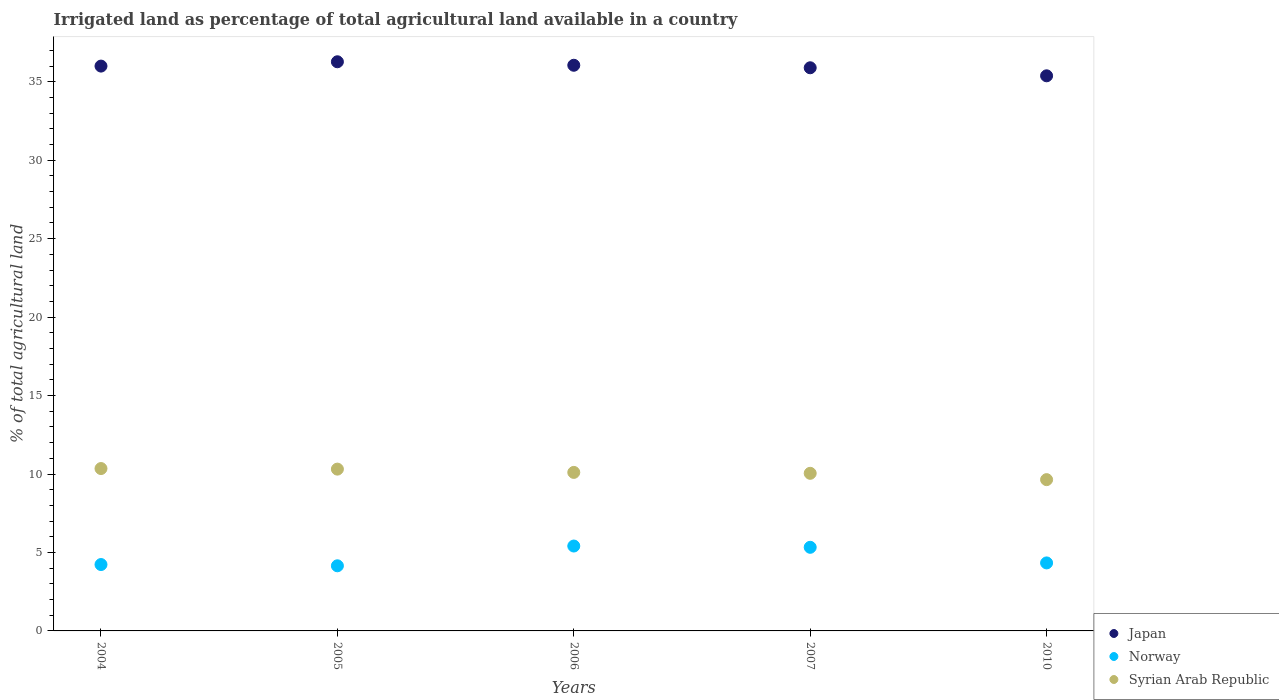What is the percentage of irrigated land in Syrian Arab Republic in 2006?
Give a very brief answer. 10.1. Across all years, what is the maximum percentage of irrigated land in Norway?
Offer a very short reply. 5.41. Across all years, what is the minimum percentage of irrigated land in Norway?
Make the answer very short. 4.15. In which year was the percentage of irrigated land in Syrian Arab Republic minimum?
Your answer should be compact. 2010. What is the total percentage of irrigated land in Japan in the graph?
Keep it short and to the point. 179.6. What is the difference between the percentage of irrigated land in Japan in 2005 and that in 2006?
Your response must be concise. 0.22. What is the difference between the percentage of irrigated land in Japan in 2006 and the percentage of irrigated land in Norway in 2007?
Provide a succinct answer. 30.72. What is the average percentage of irrigated land in Japan per year?
Ensure brevity in your answer.  35.92. In the year 2007, what is the difference between the percentage of irrigated land in Japan and percentage of irrigated land in Norway?
Offer a very short reply. 30.56. What is the ratio of the percentage of irrigated land in Norway in 2005 to that in 2007?
Provide a succinct answer. 0.78. Is the difference between the percentage of irrigated land in Japan in 2004 and 2006 greater than the difference between the percentage of irrigated land in Norway in 2004 and 2006?
Provide a succinct answer. Yes. What is the difference between the highest and the second highest percentage of irrigated land in Japan?
Provide a short and direct response. 0.22. What is the difference between the highest and the lowest percentage of irrigated land in Japan?
Ensure brevity in your answer.  0.89. Is it the case that in every year, the sum of the percentage of irrigated land in Norway and percentage of irrigated land in Syrian Arab Republic  is greater than the percentage of irrigated land in Japan?
Give a very brief answer. No. Is the percentage of irrigated land in Syrian Arab Republic strictly greater than the percentage of irrigated land in Norway over the years?
Make the answer very short. Yes. How many dotlines are there?
Give a very brief answer. 3. How many years are there in the graph?
Provide a short and direct response. 5. Are the values on the major ticks of Y-axis written in scientific E-notation?
Provide a short and direct response. No. Does the graph contain grids?
Give a very brief answer. No. How many legend labels are there?
Your answer should be very brief. 3. What is the title of the graph?
Your response must be concise. Irrigated land as percentage of total agricultural land available in a country. Does "High income: OECD" appear as one of the legend labels in the graph?
Offer a very short reply. No. What is the label or title of the Y-axis?
Your answer should be compact. % of total agricultural land. What is the % of total agricultural land in Japan in 2004?
Offer a terse response. 36. What is the % of total agricultural land of Norway in 2004?
Keep it short and to the point. 4.23. What is the % of total agricultural land in Syrian Arab Republic in 2004?
Provide a short and direct response. 10.35. What is the % of total agricultural land of Japan in 2005?
Provide a short and direct response. 36.27. What is the % of total agricultural land of Norway in 2005?
Keep it short and to the point. 4.15. What is the % of total agricultural land of Syrian Arab Republic in 2005?
Ensure brevity in your answer.  10.31. What is the % of total agricultural land in Japan in 2006?
Your answer should be compact. 36.05. What is the % of total agricultural land in Norway in 2006?
Your response must be concise. 5.41. What is the % of total agricultural land in Syrian Arab Republic in 2006?
Keep it short and to the point. 10.1. What is the % of total agricultural land in Japan in 2007?
Offer a very short reply. 35.89. What is the % of total agricultural land in Norway in 2007?
Your answer should be very brief. 5.33. What is the % of total agricultural land in Syrian Arab Republic in 2007?
Keep it short and to the point. 10.05. What is the % of total agricultural land of Japan in 2010?
Offer a very short reply. 35.38. What is the % of total agricultural land in Norway in 2010?
Keep it short and to the point. 4.33. What is the % of total agricultural land in Syrian Arab Republic in 2010?
Your answer should be very brief. 9.64. Across all years, what is the maximum % of total agricultural land in Japan?
Offer a very short reply. 36.27. Across all years, what is the maximum % of total agricultural land in Norway?
Provide a short and direct response. 5.41. Across all years, what is the maximum % of total agricultural land of Syrian Arab Republic?
Provide a succinct answer. 10.35. Across all years, what is the minimum % of total agricultural land in Japan?
Provide a succinct answer. 35.38. Across all years, what is the minimum % of total agricultural land in Norway?
Offer a very short reply. 4.15. Across all years, what is the minimum % of total agricultural land of Syrian Arab Republic?
Make the answer very short. 9.64. What is the total % of total agricultural land of Japan in the graph?
Make the answer very short. 179.6. What is the total % of total agricultural land of Norway in the graph?
Make the answer very short. 23.46. What is the total % of total agricultural land of Syrian Arab Republic in the graph?
Make the answer very short. 50.45. What is the difference between the % of total agricultural land in Japan in 2004 and that in 2005?
Your answer should be very brief. -0.28. What is the difference between the % of total agricultural land of Norway in 2004 and that in 2005?
Provide a short and direct response. 0.08. What is the difference between the % of total agricultural land of Syrian Arab Republic in 2004 and that in 2005?
Your answer should be very brief. 0.04. What is the difference between the % of total agricultural land in Japan in 2004 and that in 2006?
Provide a short and direct response. -0.05. What is the difference between the % of total agricultural land in Norway in 2004 and that in 2006?
Make the answer very short. -1.18. What is the difference between the % of total agricultural land of Syrian Arab Republic in 2004 and that in 2006?
Provide a short and direct response. 0.25. What is the difference between the % of total agricultural land in Japan in 2004 and that in 2007?
Your response must be concise. 0.11. What is the difference between the % of total agricultural land of Norway in 2004 and that in 2007?
Provide a succinct answer. -1.1. What is the difference between the % of total agricultural land in Syrian Arab Republic in 2004 and that in 2007?
Keep it short and to the point. 0.3. What is the difference between the % of total agricultural land of Japan in 2004 and that in 2010?
Provide a succinct answer. 0.62. What is the difference between the % of total agricultural land in Norway in 2004 and that in 2010?
Your answer should be very brief. -0.1. What is the difference between the % of total agricultural land in Syrian Arab Republic in 2004 and that in 2010?
Your answer should be very brief. 0.71. What is the difference between the % of total agricultural land of Japan in 2005 and that in 2006?
Your answer should be very brief. 0.22. What is the difference between the % of total agricultural land in Norway in 2005 and that in 2006?
Make the answer very short. -1.26. What is the difference between the % of total agricultural land of Syrian Arab Republic in 2005 and that in 2006?
Your answer should be very brief. 0.21. What is the difference between the % of total agricultural land of Japan in 2005 and that in 2007?
Provide a succinct answer. 0.38. What is the difference between the % of total agricultural land in Norway in 2005 and that in 2007?
Give a very brief answer. -1.18. What is the difference between the % of total agricultural land of Syrian Arab Republic in 2005 and that in 2007?
Your answer should be very brief. 0.27. What is the difference between the % of total agricultural land of Japan in 2005 and that in 2010?
Your response must be concise. 0.89. What is the difference between the % of total agricultural land of Norway in 2005 and that in 2010?
Offer a very short reply. -0.18. What is the difference between the % of total agricultural land of Syrian Arab Republic in 2005 and that in 2010?
Your answer should be very brief. 0.67. What is the difference between the % of total agricultural land in Japan in 2006 and that in 2007?
Your answer should be very brief. 0.16. What is the difference between the % of total agricultural land in Norway in 2006 and that in 2007?
Offer a very short reply. 0.08. What is the difference between the % of total agricultural land of Syrian Arab Republic in 2006 and that in 2007?
Give a very brief answer. 0.06. What is the difference between the % of total agricultural land of Japan in 2006 and that in 2010?
Provide a short and direct response. 0.67. What is the difference between the % of total agricultural land in Norway in 2006 and that in 2010?
Make the answer very short. 1.08. What is the difference between the % of total agricultural land in Syrian Arab Republic in 2006 and that in 2010?
Offer a terse response. 0.46. What is the difference between the % of total agricultural land of Japan in 2007 and that in 2010?
Give a very brief answer. 0.51. What is the difference between the % of total agricultural land of Syrian Arab Republic in 2007 and that in 2010?
Your response must be concise. 0.4. What is the difference between the % of total agricultural land in Japan in 2004 and the % of total agricultural land in Norway in 2005?
Provide a succinct answer. 31.85. What is the difference between the % of total agricultural land in Japan in 2004 and the % of total agricultural land in Syrian Arab Republic in 2005?
Provide a short and direct response. 25.69. What is the difference between the % of total agricultural land of Norway in 2004 and the % of total agricultural land of Syrian Arab Republic in 2005?
Offer a terse response. -6.08. What is the difference between the % of total agricultural land of Japan in 2004 and the % of total agricultural land of Norway in 2006?
Your answer should be very brief. 30.59. What is the difference between the % of total agricultural land in Japan in 2004 and the % of total agricultural land in Syrian Arab Republic in 2006?
Keep it short and to the point. 25.9. What is the difference between the % of total agricultural land of Norway in 2004 and the % of total agricultural land of Syrian Arab Republic in 2006?
Provide a short and direct response. -5.87. What is the difference between the % of total agricultural land of Japan in 2004 and the % of total agricultural land of Norway in 2007?
Your answer should be compact. 30.67. What is the difference between the % of total agricultural land in Japan in 2004 and the % of total agricultural land in Syrian Arab Republic in 2007?
Make the answer very short. 25.95. What is the difference between the % of total agricultural land of Norway in 2004 and the % of total agricultural land of Syrian Arab Republic in 2007?
Your response must be concise. -5.81. What is the difference between the % of total agricultural land in Japan in 2004 and the % of total agricultural land in Norway in 2010?
Make the answer very short. 31.67. What is the difference between the % of total agricultural land in Japan in 2004 and the % of total agricultural land in Syrian Arab Republic in 2010?
Ensure brevity in your answer.  26.36. What is the difference between the % of total agricultural land of Norway in 2004 and the % of total agricultural land of Syrian Arab Republic in 2010?
Your answer should be compact. -5.41. What is the difference between the % of total agricultural land in Japan in 2005 and the % of total agricultural land in Norway in 2006?
Provide a succinct answer. 30.86. What is the difference between the % of total agricultural land in Japan in 2005 and the % of total agricultural land in Syrian Arab Republic in 2006?
Provide a succinct answer. 26.17. What is the difference between the % of total agricultural land of Norway in 2005 and the % of total agricultural land of Syrian Arab Republic in 2006?
Keep it short and to the point. -5.95. What is the difference between the % of total agricultural land in Japan in 2005 and the % of total agricultural land in Norway in 2007?
Your answer should be very brief. 30.95. What is the difference between the % of total agricultural land of Japan in 2005 and the % of total agricultural land of Syrian Arab Republic in 2007?
Keep it short and to the point. 26.23. What is the difference between the % of total agricultural land of Norway in 2005 and the % of total agricultural land of Syrian Arab Republic in 2007?
Make the answer very short. -5.89. What is the difference between the % of total agricultural land of Japan in 2005 and the % of total agricultural land of Norway in 2010?
Your answer should be compact. 31.94. What is the difference between the % of total agricultural land of Japan in 2005 and the % of total agricultural land of Syrian Arab Republic in 2010?
Make the answer very short. 26.63. What is the difference between the % of total agricultural land of Norway in 2005 and the % of total agricultural land of Syrian Arab Republic in 2010?
Provide a succinct answer. -5.49. What is the difference between the % of total agricultural land in Japan in 2006 and the % of total agricultural land in Norway in 2007?
Keep it short and to the point. 30.72. What is the difference between the % of total agricultural land in Japan in 2006 and the % of total agricultural land in Syrian Arab Republic in 2007?
Give a very brief answer. 26.01. What is the difference between the % of total agricultural land in Norway in 2006 and the % of total agricultural land in Syrian Arab Republic in 2007?
Your response must be concise. -4.63. What is the difference between the % of total agricultural land in Japan in 2006 and the % of total agricultural land in Norway in 2010?
Keep it short and to the point. 31.72. What is the difference between the % of total agricultural land in Japan in 2006 and the % of total agricultural land in Syrian Arab Republic in 2010?
Give a very brief answer. 26.41. What is the difference between the % of total agricultural land of Norway in 2006 and the % of total agricultural land of Syrian Arab Republic in 2010?
Your answer should be very brief. -4.23. What is the difference between the % of total agricultural land of Japan in 2007 and the % of total agricultural land of Norway in 2010?
Keep it short and to the point. 31.56. What is the difference between the % of total agricultural land of Japan in 2007 and the % of total agricultural land of Syrian Arab Republic in 2010?
Your answer should be compact. 26.25. What is the difference between the % of total agricultural land in Norway in 2007 and the % of total agricultural land in Syrian Arab Republic in 2010?
Offer a terse response. -4.31. What is the average % of total agricultural land in Japan per year?
Offer a very short reply. 35.92. What is the average % of total agricultural land in Norway per year?
Your answer should be compact. 4.69. What is the average % of total agricultural land of Syrian Arab Republic per year?
Offer a very short reply. 10.09. In the year 2004, what is the difference between the % of total agricultural land in Japan and % of total agricultural land in Norway?
Keep it short and to the point. 31.77. In the year 2004, what is the difference between the % of total agricultural land in Japan and % of total agricultural land in Syrian Arab Republic?
Keep it short and to the point. 25.65. In the year 2004, what is the difference between the % of total agricultural land of Norway and % of total agricultural land of Syrian Arab Republic?
Offer a terse response. -6.12. In the year 2005, what is the difference between the % of total agricultural land of Japan and % of total agricultural land of Norway?
Provide a succinct answer. 32.12. In the year 2005, what is the difference between the % of total agricultural land of Japan and % of total agricultural land of Syrian Arab Republic?
Give a very brief answer. 25.96. In the year 2005, what is the difference between the % of total agricultural land in Norway and % of total agricultural land in Syrian Arab Republic?
Provide a succinct answer. -6.16. In the year 2006, what is the difference between the % of total agricultural land of Japan and % of total agricultural land of Norway?
Offer a very short reply. 30.64. In the year 2006, what is the difference between the % of total agricultural land of Japan and % of total agricultural land of Syrian Arab Republic?
Keep it short and to the point. 25.95. In the year 2006, what is the difference between the % of total agricultural land of Norway and % of total agricultural land of Syrian Arab Republic?
Make the answer very short. -4.69. In the year 2007, what is the difference between the % of total agricultural land in Japan and % of total agricultural land in Norway?
Provide a short and direct response. 30.56. In the year 2007, what is the difference between the % of total agricultural land of Japan and % of total agricultural land of Syrian Arab Republic?
Ensure brevity in your answer.  25.85. In the year 2007, what is the difference between the % of total agricultural land of Norway and % of total agricultural land of Syrian Arab Republic?
Give a very brief answer. -4.72. In the year 2010, what is the difference between the % of total agricultural land of Japan and % of total agricultural land of Norway?
Your response must be concise. 31.05. In the year 2010, what is the difference between the % of total agricultural land of Japan and % of total agricultural land of Syrian Arab Republic?
Provide a short and direct response. 25.74. In the year 2010, what is the difference between the % of total agricultural land of Norway and % of total agricultural land of Syrian Arab Republic?
Your answer should be compact. -5.31. What is the ratio of the % of total agricultural land of Japan in 2004 to that in 2005?
Ensure brevity in your answer.  0.99. What is the ratio of the % of total agricultural land in Norway in 2004 to that in 2005?
Your answer should be compact. 1.02. What is the ratio of the % of total agricultural land in Syrian Arab Republic in 2004 to that in 2005?
Keep it short and to the point. 1. What is the ratio of the % of total agricultural land in Japan in 2004 to that in 2006?
Keep it short and to the point. 1. What is the ratio of the % of total agricultural land of Norway in 2004 to that in 2006?
Give a very brief answer. 0.78. What is the ratio of the % of total agricultural land of Syrian Arab Republic in 2004 to that in 2006?
Your answer should be very brief. 1.02. What is the ratio of the % of total agricultural land in Japan in 2004 to that in 2007?
Your response must be concise. 1. What is the ratio of the % of total agricultural land in Norway in 2004 to that in 2007?
Keep it short and to the point. 0.79. What is the ratio of the % of total agricultural land in Syrian Arab Republic in 2004 to that in 2007?
Offer a terse response. 1.03. What is the ratio of the % of total agricultural land in Japan in 2004 to that in 2010?
Offer a terse response. 1.02. What is the ratio of the % of total agricultural land of Norway in 2004 to that in 2010?
Ensure brevity in your answer.  0.98. What is the ratio of the % of total agricultural land of Syrian Arab Republic in 2004 to that in 2010?
Make the answer very short. 1.07. What is the ratio of the % of total agricultural land of Japan in 2005 to that in 2006?
Provide a succinct answer. 1.01. What is the ratio of the % of total agricultural land of Norway in 2005 to that in 2006?
Keep it short and to the point. 0.77. What is the ratio of the % of total agricultural land in Syrian Arab Republic in 2005 to that in 2006?
Provide a succinct answer. 1.02. What is the ratio of the % of total agricultural land of Japan in 2005 to that in 2007?
Provide a succinct answer. 1.01. What is the ratio of the % of total agricultural land of Norway in 2005 to that in 2007?
Your answer should be very brief. 0.78. What is the ratio of the % of total agricultural land of Syrian Arab Republic in 2005 to that in 2007?
Make the answer very short. 1.03. What is the ratio of the % of total agricultural land of Japan in 2005 to that in 2010?
Your response must be concise. 1.03. What is the ratio of the % of total agricultural land in Norway in 2005 to that in 2010?
Offer a terse response. 0.96. What is the ratio of the % of total agricultural land of Syrian Arab Republic in 2005 to that in 2010?
Give a very brief answer. 1.07. What is the ratio of the % of total agricultural land in Japan in 2006 to that in 2007?
Your response must be concise. 1. What is the ratio of the % of total agricultural land of Norway in 2006 to that in 2007?
Offer a very short reply. 1.02. What is the ratio of the % of total agricultural land of Norway in 2006 to that in 2010?
Ensure brevity in your answer.  1.25. What is the ratio of the % of total agricultural land in Syrian Arab Republic in 2006 to that in 2010?
Provide a succinct answer. 1.05. What is the ratio of the % of total agricultural land of Japan in 2007 to that in 2010?
Your answer should be compact. 1.01. What is the ratio of the % of total agricultural land in Norway in 2007 to that in 2010?
Provide a short and direct response. 1.23. What is the ratio of the % of total agricultural land in Syrian Arab Republic in 2007 to that in 2010?
Your response must be concise. 1.04. What is the difference between the highest and the second highest % of total agricultural land of Japan?
Ensure brevity in your answer.  0.22. What is the difference between the highest and the second highest % of total agricultural land in Norway?
Your answer should be compact. 0.08. What is the difference between the highest and the second highest % of total agricultural land in Syrian Arab Republic?
Your answer should be compact. 0.04. What is the difference between the highest and the lowest % of total agricultural land in Japan?
Give a very brief answer. 0.89. What is the difference between the highest and the lowest % of total agricultural land in Norway?
Your answer should be compact. 1.26. What is the difference between the highest and the lowest % of total agricultural land in Syrian Arab Republic?
Ensure brevity in your answer.  0.71. 